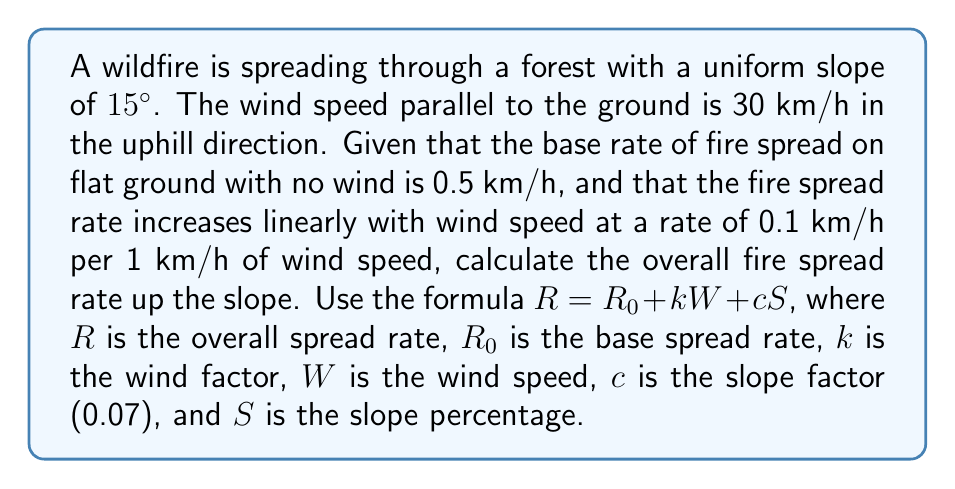Give your solution to this math problem. To solve this problem, we'll follow these steps:

1) First, we need to identify the given values:
   $R_0 = 0.5$ km/h (base spread rate)
   $k = 0.1$ (wind factor)
   $W = 30$ km/h (wind speed)
   $c = 0.07$ (slope factor)
   Slope angle = 15°

2) We need to convert the slope angle to a percentage:
   $S = \tan(15°) \times 100\%$
   $S = 0.2679 \times 100\% = 26.79\%$

3) Now we can plug these values into the formula:
   $R = R_0 + kW + cS$
   $R = 0.5 + 0.1(30) + 0.07(26.79)$

4) Let's calculate each term:
   $0.1(30) = 3$
   $0.07(26.79) = 1.8753$

5) Now we can sum up:
   $R = 0.5 + 3 + 1.8753 = 5.3753$ km/h

Therefore, the overall fire spread rate up the slope is approximately 5.38 km/h.
Answer: 5.38 km/h 